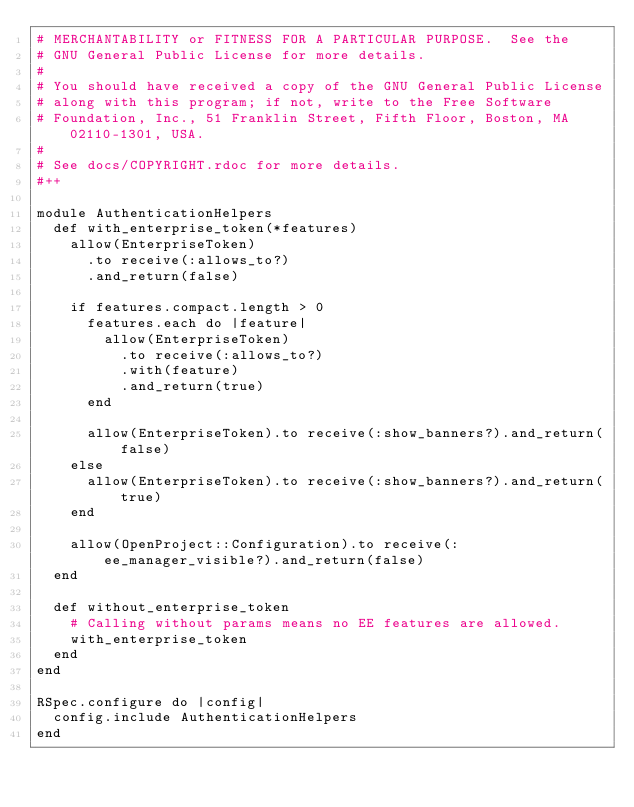<code> <loc_0><loc_0><loc_500><loc_500><_Ruby_># MERCHANTABILITY or FITNESS FOR A PARTICULAR PURPOSE.  See the
# GNU General Public License for more details.
#
# You should have received a copy of the GNU General Public License
# along with this program; if not, write to the Free Software
# Foundation, Inc., 51 Franklin Street, Fifth Floor, Boston, MA  02110-1301, USA.
#
# See docs/COPYRIGHT.rdoc for more details.
#++

module AuthenticationHelpers
  def with_enterprise_token(*features)
    allow(EnterpriseToken)
      .to receive(:allows_to?)
      .and_return(false)

    if features.compact.length > 0
      features.each do |feature|
        allow(EnterpriseToken)
          .to receive(:allows_to?)
          .with(feature)
          .and_return(true)
      end

      allow(EnterpriseToken).to receive(:show_banners?).and_return(false)
    else
      allow(EnterpriseToken).to receive(:show_banners?).and_return(true)
    end

    allow(OpenProject::Configuration).to receive(:ee_manager_visible?).and_return(false)
  end

  def without_enterprise_token
    # Calling without params means no EE features are allowed.
    with_enterprise_token
  end
end

RSpec.configure do |config|
  config.include AuthenticationHelpers
end
</code> 